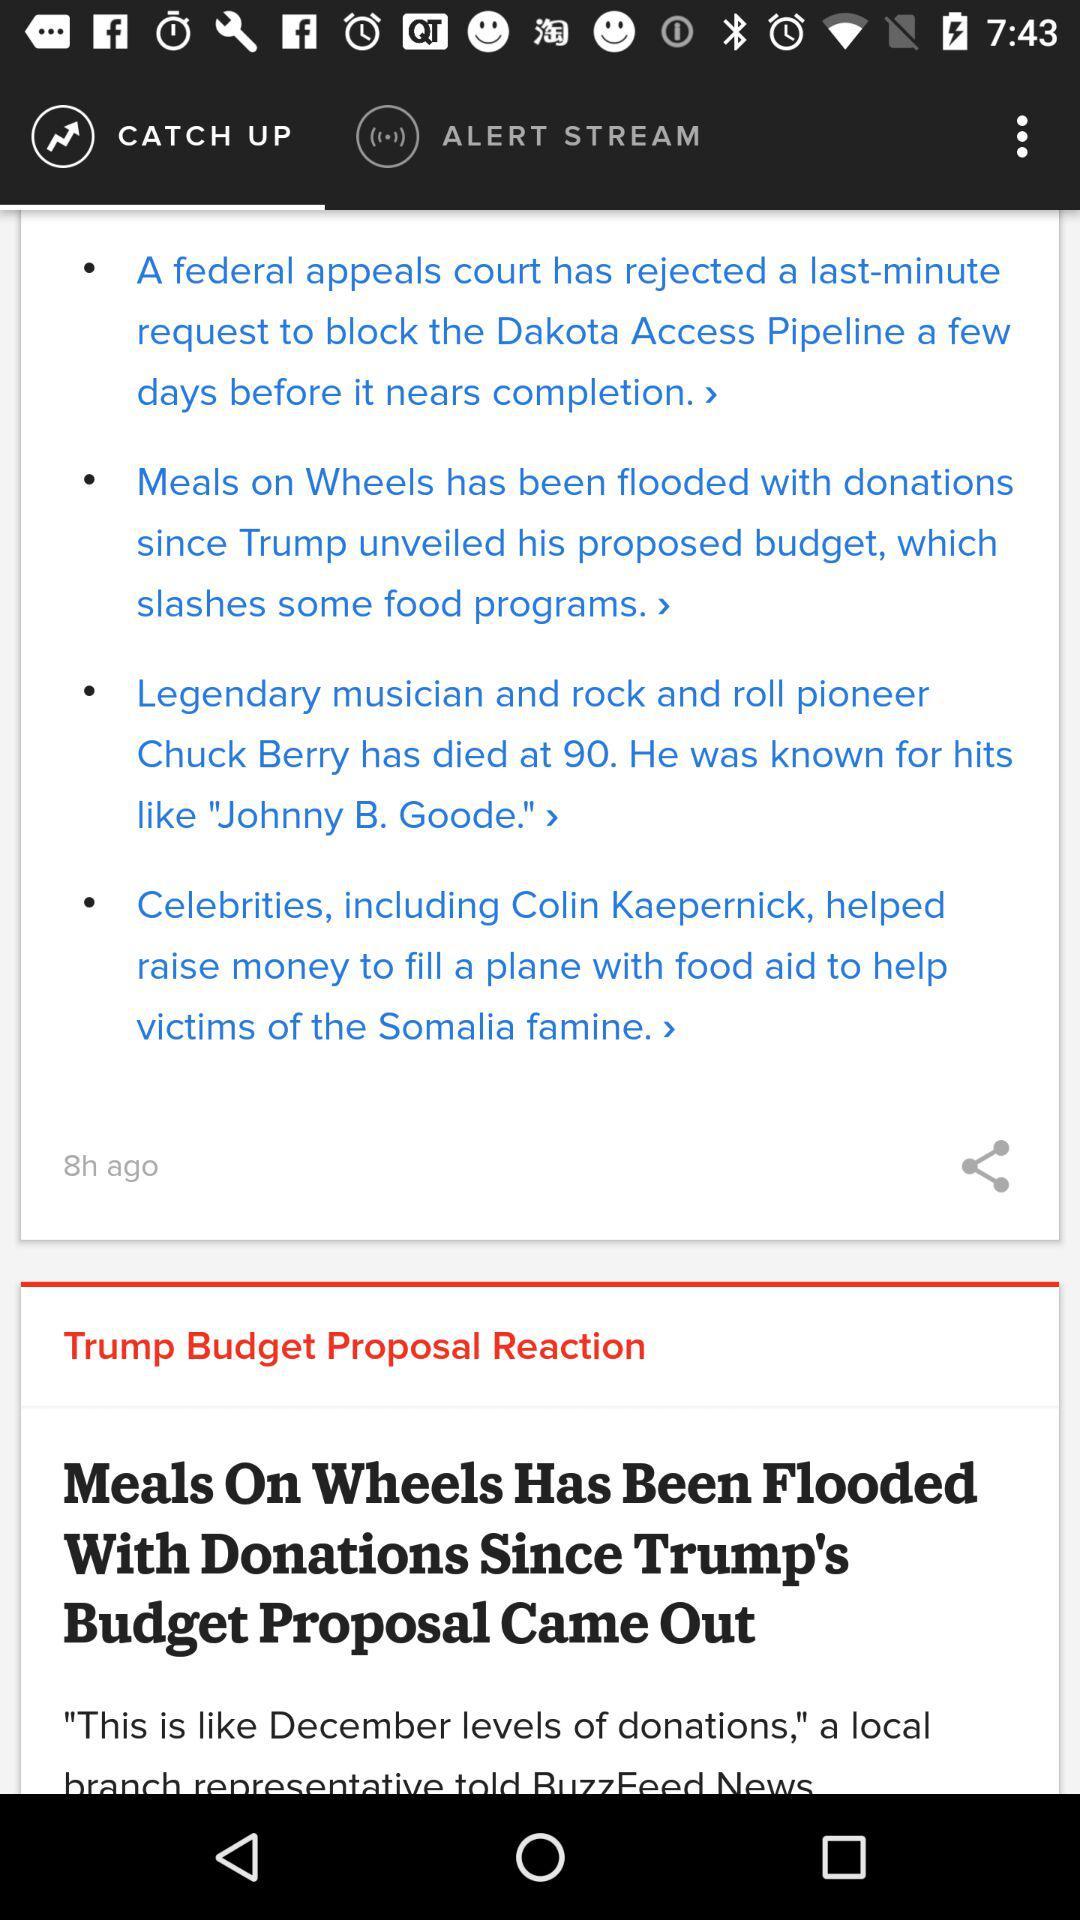How many articles are in "ALERT STREAM"?
When the provided information is insufficient, respond with <no answer>. <no answer> 